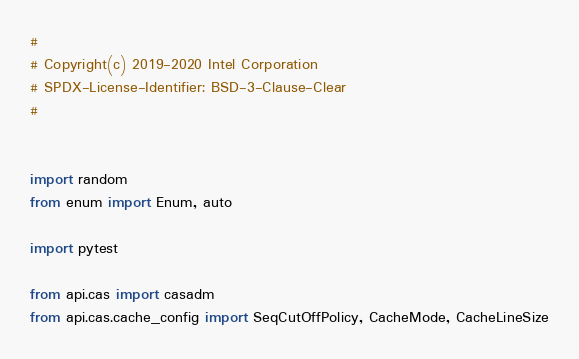<code> <loc_0><loc_0><loc_500><loc_500><_Python_>#
# Copyright(c) 2019-2020 Intel Corporation
# SPDX-License-Identifier: BSD-3-Clause-Clear
#


import random
from enum import Enum, auto

import pytest

from api.cas import casadm
from api.cas.cache_config import SeqCutOffPolicy, CacheMode, CacheLineSize</code> 